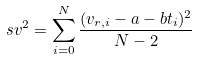Convert formula to latex. <formula><loc_0><loc_0><loc_500><loc_500>\ s v ^ { 2 } = \sum _ { i = 0 } ^ { N } \frac { ( v _ { r , i } - a - b t _ { i } ) ^ { 2 } } { N - 2 }</formula> 